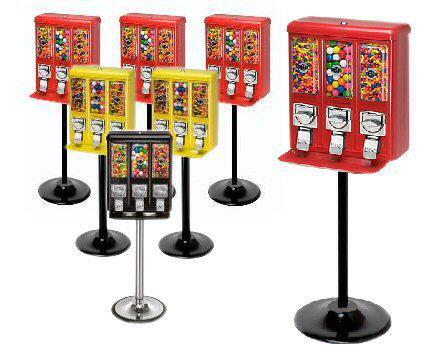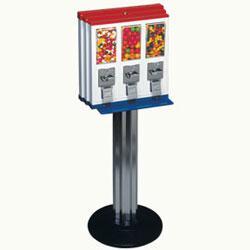The first image is the image on the left, the second image is the image on the right. Evaluate the accuracy of this statement regarding the images: "There are no more than two machines in the photo.". Is it true? Answer yes or no. No. The first image is the image on the left, the second image is the image on the right. Evaluate the accuracy of this statement regarding the images: "An image shows just one vending machine, which has a trio of dispensers combined into one rectangular box shape.". Is it true? Answer yes or no. Yes. 